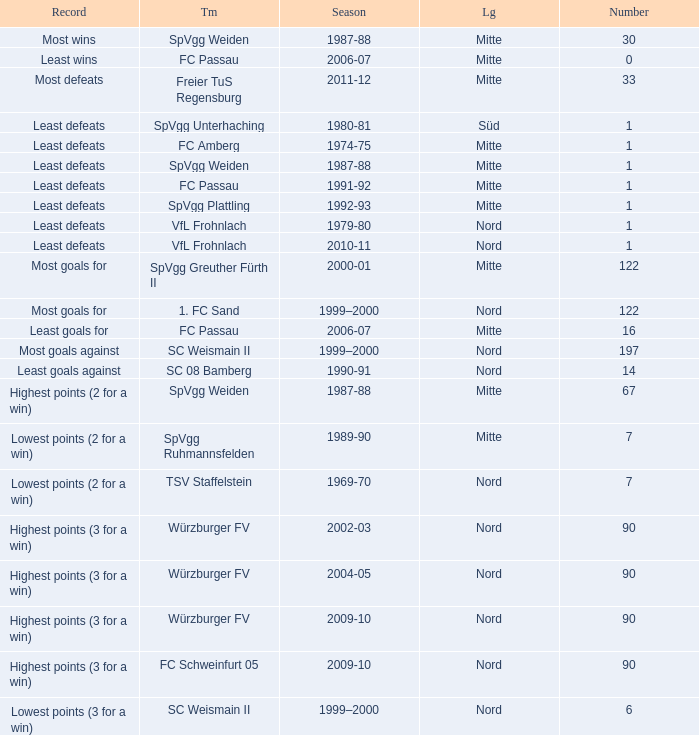What team has 2000-01 as the season? SpVgg Greuther Fürth II. 